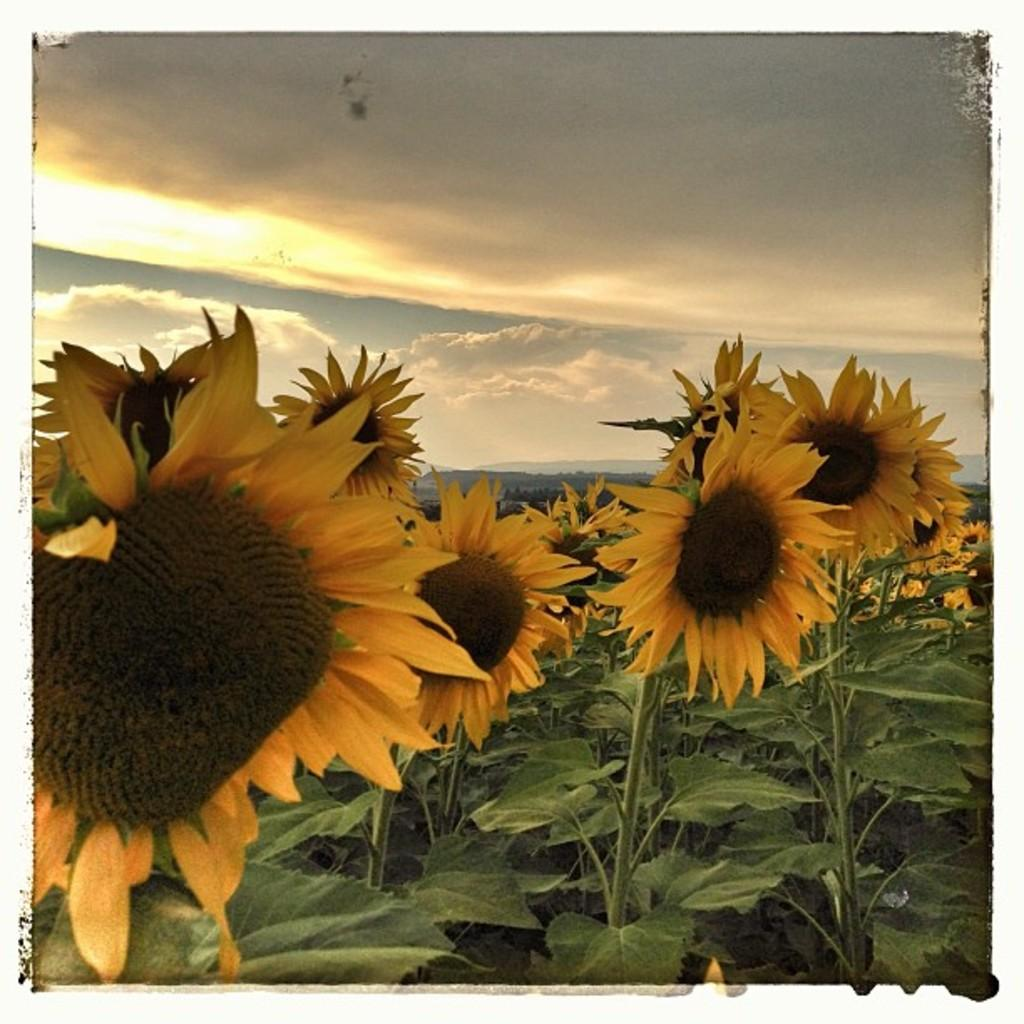What type of plants can be seen in the image? There are plants with flowers in the image. What can be seen in the background of the image? The sky is visible in the background of the image. What type of cloth is being used for the meeting in the image? There is no meeting or cloth present in the image; it features plants with flowers and the sky in the background. How many snakes can be seen slithering through the flowers in the image? There are no snakes present in the image; it features plants with flowers and the sky in the background. 